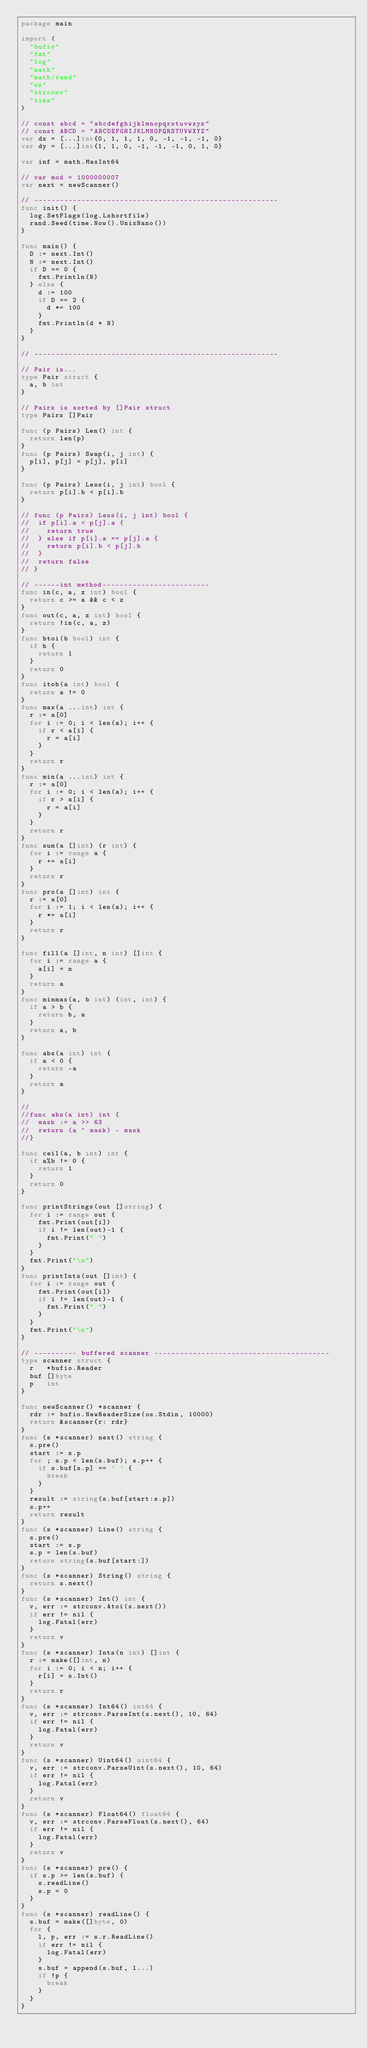<code> <loc_0><loc_0><loc_500><loc_500><_Go_>package main

import (
	"bufio"
	"fmt"
	"log"
	"math"
	"math/rand"
	"os"
	"strconv"
	"time"
)

// const abcd = "abcdefghijklmnopqrstuvwxyz"
// const ABCD = "ABCDEFGHIJKLMNOPQRSTUVWXYZ"
var dx = [...]int{0, 1, 1, 1, 0, -1, -1, -1, 0}
var dy = [...]int{1, 1, 0, -1, -1, -1, 0, 1, 0}

var inf = math.MaxInt64

// var mod = 1000000007
var next = newScanner()

// ---------------------------------------------------------
func init() {
	log.SetFlags(log.Lshortfile)
	rand.Seed(time.Now().UnixNano())
}

func main() {
	D := next.Int()
	N := next.Int()
	if D == 0 {
		fmt.Println(N)
	} else {
		d := 100
		if D == 2 {
			d *= 100
		}
		fmt.Println(d * N)
	}
}

// ---------------------------------------------------------

// Pair is...
type Pair struct {
	a, b int
}

// Pairs is sorted by []Pair struct
type Pairs []Pair

func (p Pairs) Len() int {
	return len(p)
}
func (p Pairs) Swap(i, j int) {
	p[i], p[j] = p[j], p[i]
}

func (p Pairs) Less(i, j int) bool {
	return p[i].b < p[i].b
}

// func (p Pairs) Less(i, j int) bool {
// 	if p[i].a < p[j].a {
// 		return true
// 	} else if p[i].a == p[j].a {
// 		return p[i].b < p[j].b
// 	}
// 	return false
// }

// ------int method-------------------------
func in(c, a, z int) bool {
	return c >= a && c < z
}
func out(c, a, z int) bool {
	return !in(c, a, z)
}
func btoi(b bool) int {
	if b {
		return 1
	}
	return 0
}
func itob(a int) bool {
	return a != 0
}
func max(a ...int) int {
	r := a[0]
	for i := 0; i < len(a); i++ {
		if r < a[i] {
			r = a[i]
		}
	}
	return r
}
func min(a ...int) int {
	r := a[0]
	for i := 0; i < len(a); i++ {
		if r > a[i] {
			r = a[i]
		}
	}
	return r
}
func sum(a []int) (r int) {
	for i := range a {
		r += a[i]
	}
	return r
}
func pro(a []int) int {
	r := a[0]
	for i := 1; i < len(a); i++ {
		r *= a[i]
	}
	return r
}

func fill(a []int, n int) []int {
	for i := range a {
		a[i] = n
	}
	return a
}
func minmax(a, b int) (int, int) {
	if a > b {
		return b, a
	}
	return a, b
}

func abs(a int) int {
	if a < 0 {
		return -a
	}
	return a
}

//
//func abs(a int) int {
//	mask := a >> 63
//	return (a ^ mask) - mask
//}

func ceil(a, b int) int {
	if a%b != 0 {
		return 1
	}
	return 0
}

func printStrings(out []string) {
	for i := range out {
		fmt.Print(out[i])
		if i != len(out)-1 {
			fmt.Print(" ")
		}
	}
	fmt.Print("\n")
}
func printInts(out []int) {
	for i := range out {
		fmt.Print(out[i])
		if i != len(out)-1 {
			fmt.Print(" ")
		}
	}
	fmt.Print("\n")
}

// ---------- buffered scanner -----------------------------------------
type scanner struct {
	r   *bufio.Reader
	buf []byte
	p   int
}

func newScanner() *scanner {
	rdr := bufio.NewReaderSize(os.Stdin, 10000)
	return &scanner{r: rdr}
}
func (s *scanner) next() string {
	s.pre()
	start := s.p
	for ; s.p < len(s.buf); s.p++ {
		if s.buf[s.p] == ' ' {
			break
		}
	}
	result := string(s.buf[start:s.p])
	s.p++
	return result
}
func (s *scanner) Line() string {
	s.pre()
	start := s.p
	s.p = len(s.buf)
	return string(s.buf[start:])
}
func (s *scanner) String() string {
	return s.next()
}
func (s *scanner) Int() int {
	v, err := strconv.Atoi(s.next())
	if err != nil {
		log.Fatal(err)
	}
	return v
}
func (s *scanner) Ints(n int) []int {
	r := make([]int, n)
	for i := 0; i < n; i++ {
		r[i] = s.Int()
	}
	return r
}
func (s *scanner) Int64() int64 {
	v, err := strconv.ParseInt(s.next(), 10, 64)
	if err != nil {
		log.Fatal(err)
	}
	return v
}
func (s *scanner) Uint64() uint64 {
	v, err := strconv.ParseUint(s.next(), 10, 64)
	if err != nil {
		log.Fatal(err)
	}
	return v
}
func (s *scanner) Float64() float64 {
	v, err := strconv.ParseFloat(s.next(), 64)
	if err != nil {
		log.Fatal(err)
	}
	return v
}
func (s *scanner) pre() {
	if s.p >= len(s.buf) {
		s.readLine()
		s.p = 0
	}
}
func (s *scanner) readLine() {
	s.buf = make([]byte, 0)
	for {
		l, p, err := s.r.ReadLine()
		if err != nil {
			log.Fatal(err)
		}
		s.buf = append(s.buf, l...)
		if !p {
			break
		}
	}
}
</code> 